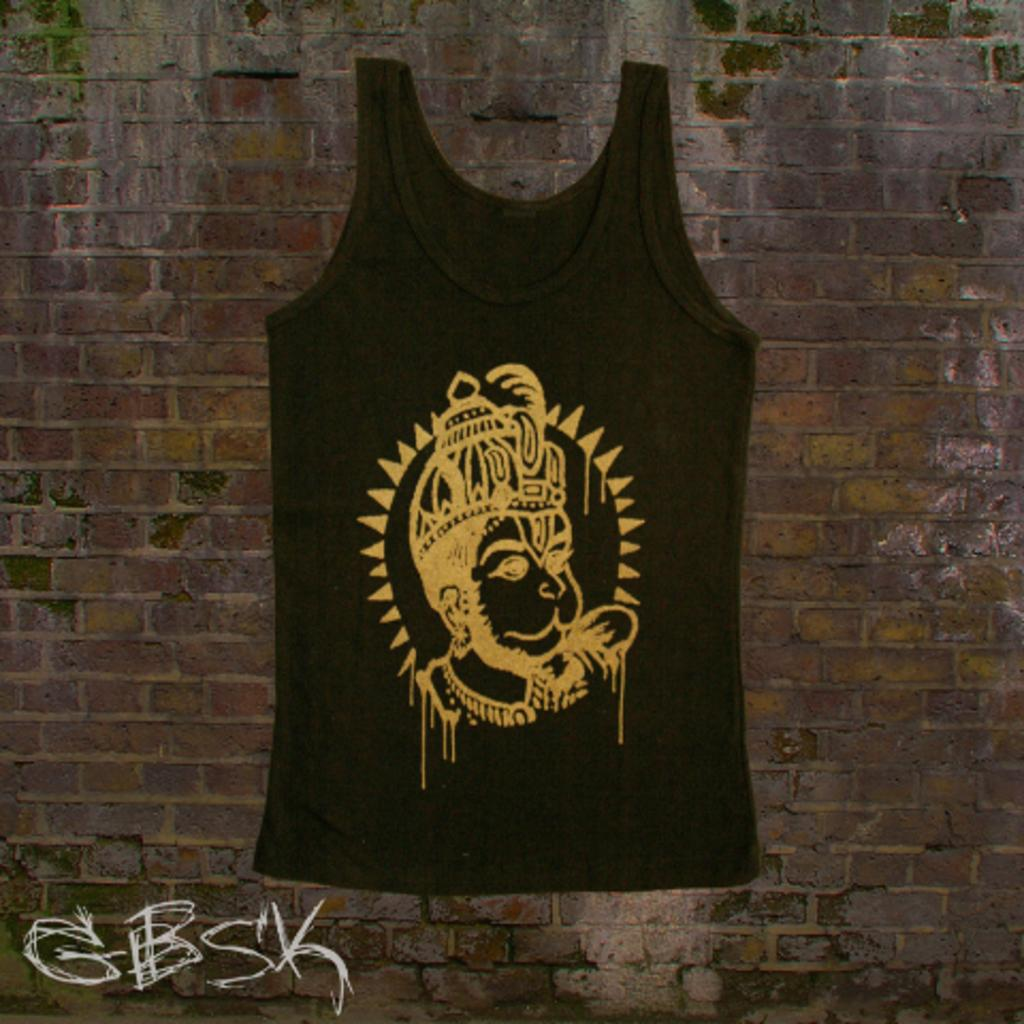What is hanging on the wall in the image? There is a printed vest on the wall in the image. Where can you find the letters in the image? The letters are in the bottom left corner of the image. What type of toy is visible on the scale in the image? There is no toy or scale present in the image. What color is the bag hanging on the wall next to the printed vest? There is no bag present in the image; only the printed vest is mentioned. 